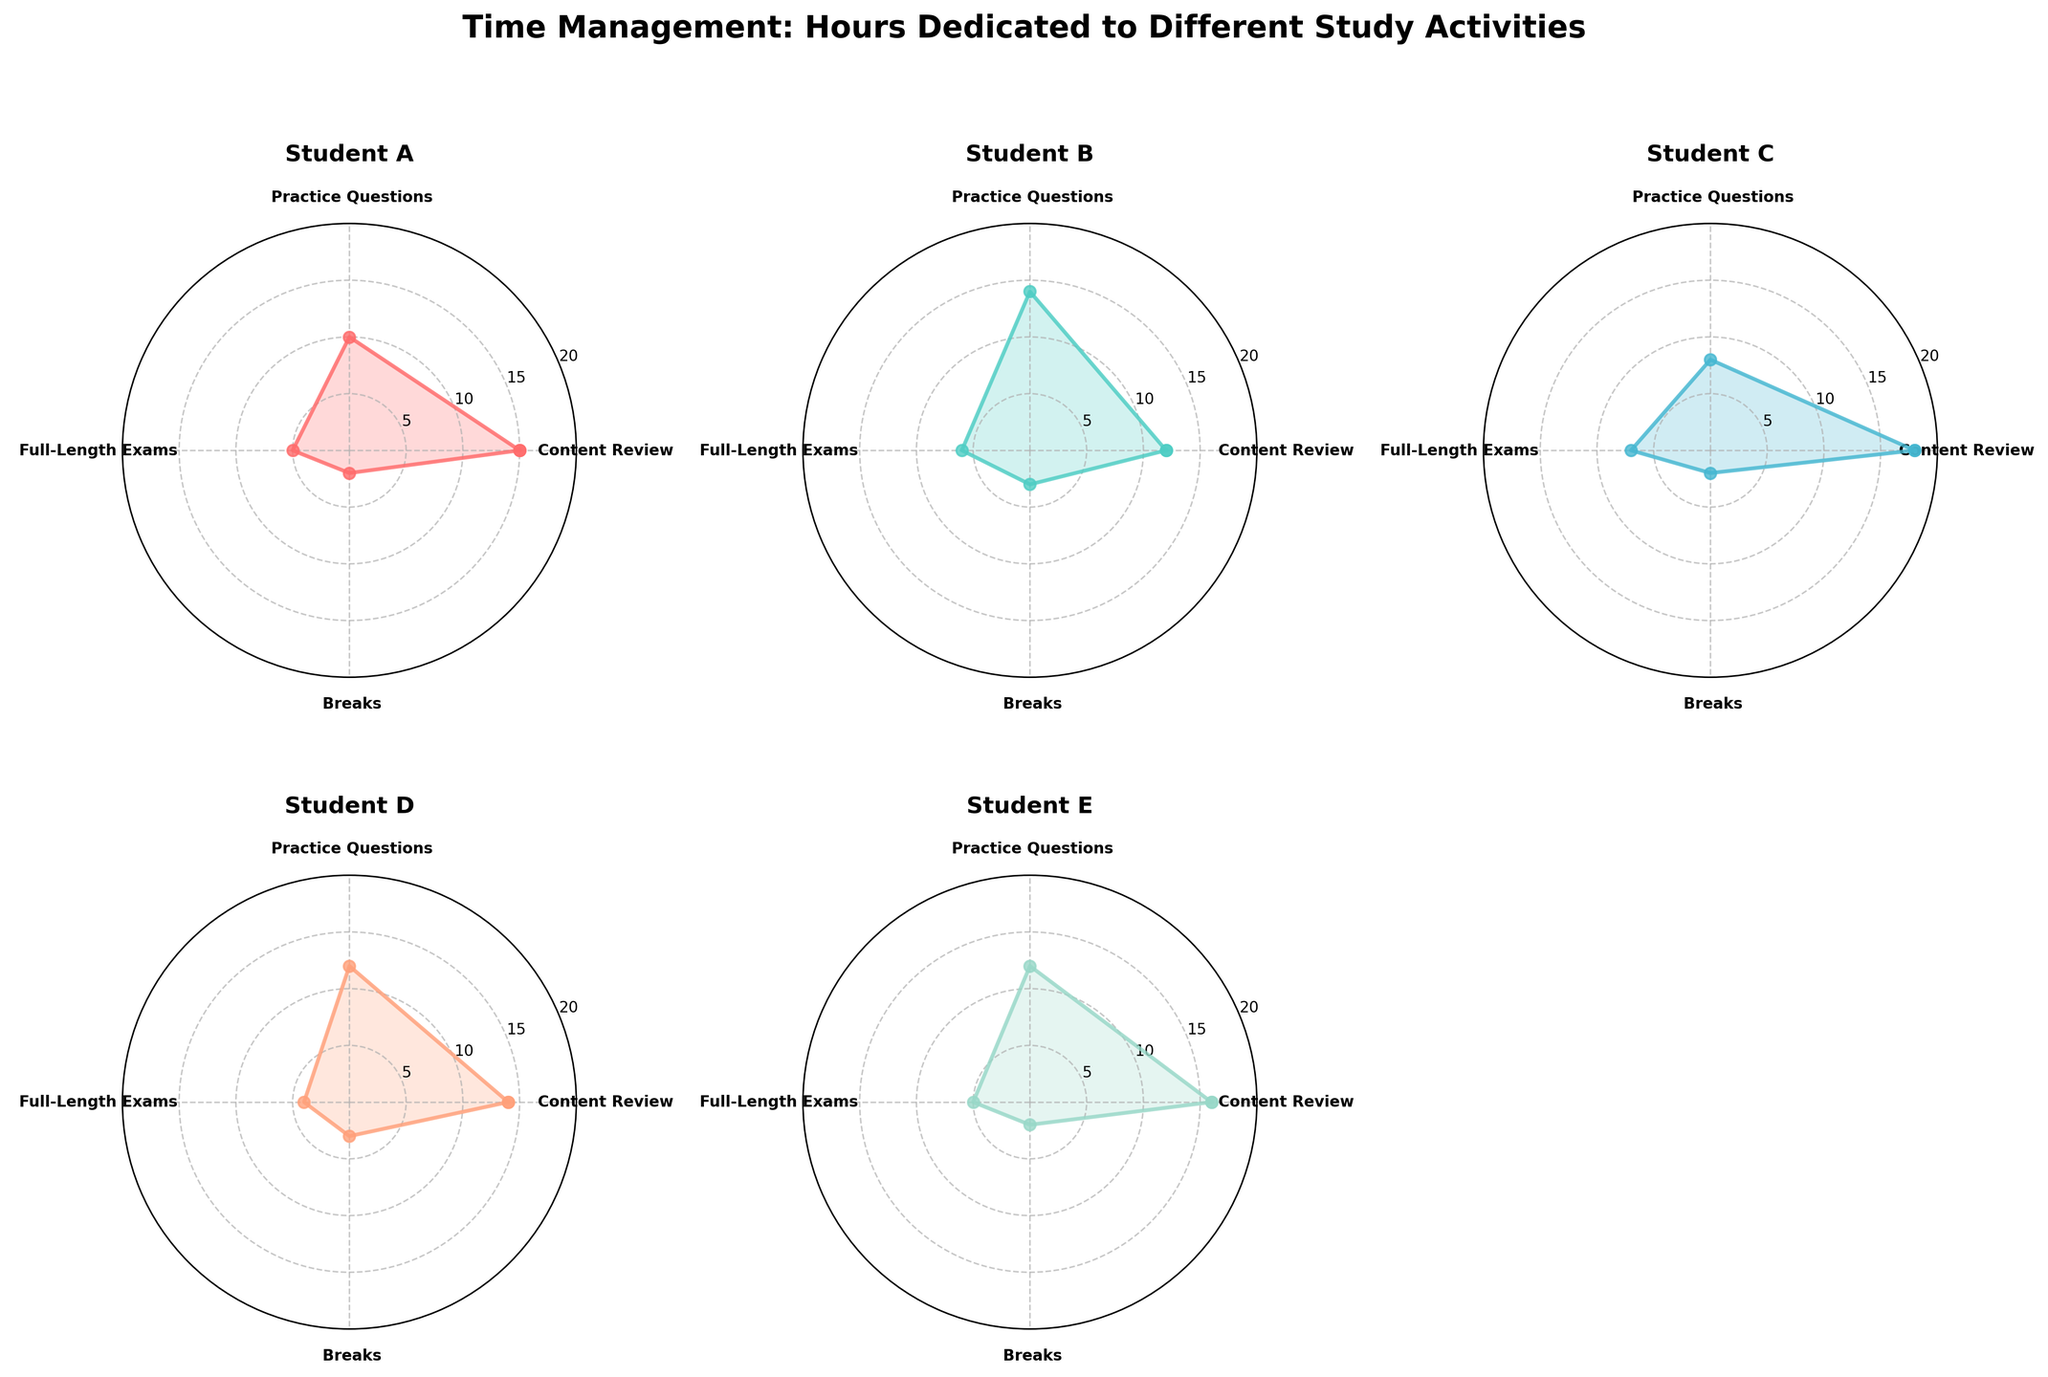What is the title of the figure? The title can be easily located at the top of the chart, which summarizes the entire visualization. In this case, the title is "Time Management: Hours Dedicated to Different Study Activities".
Answer: Time Management: Hours Dedicated to Different Study Activities How many subjects are included in this study? The radar chart has subplots for different subjects, and counting the number of these subplots will reveal the number of subjects. Here, there are subplots for five subjects: Student A, B, C, D, and E.
Answer: 5 Which student spends the most time on content review? By looking at the 'Content Review' section on each radar chart, we can see which student has the highest value. Student C has the highest value for content review at 18 hours.
Answer: Student C What are the different study activities considered in this figure? The labels on the radar charts indicate the different study activities, which include Content Review, Practice Questions, Full-Length Exams, and Breaks.
Answer: Content Review, Practice Questions, Full-Length Exams, Breaks Which student dedicates the least time to practice questions? By comparing the 'Practice Questions' values on each radar chart, we can see that Student C dedicates the least time with 8 hours.
Answer: Student C What is the total time spent studying by Student E? Adding the hours dedicated to each activity for Student E: 16 (Content Review) + 12 (Practice Questions) + 5 (Full-Length Exams) + 2 (Breaks) = 35 hours.
Answer: 35 hours Among all students, who has the most balanced study plan based on the radar charts? Balance can be inferred from how evenly the values for each activity are distributed in the radar chart. Student D has a relatively balanced chart with values close to each other (14, 12, 4, 3).
Answer: Student D How many hours, in total, do Students D and E dedicate to Breaks? Student D dedicates 3 hours and Student E dedicates 2 hours, so the total is 3 + 2 = 5 hours.
Answer: 5 hours What is the difference in time spent on Full-Length Exams between Student B and Student C? Student B spends 6 hours and Student C spends 7 hours on Full-Length Exams. The difference is 7 - 6 = 1 hour.
Answer: 1 hour Which student’s study plan shows the least number of hours dedicated to breaks? By looking at the data points for breaks on each radar chart, we see that Student A, Student C, and Student E all dedicate 2 hours to breaks, which is the least.
Answer: Student A, Student C, Student E 